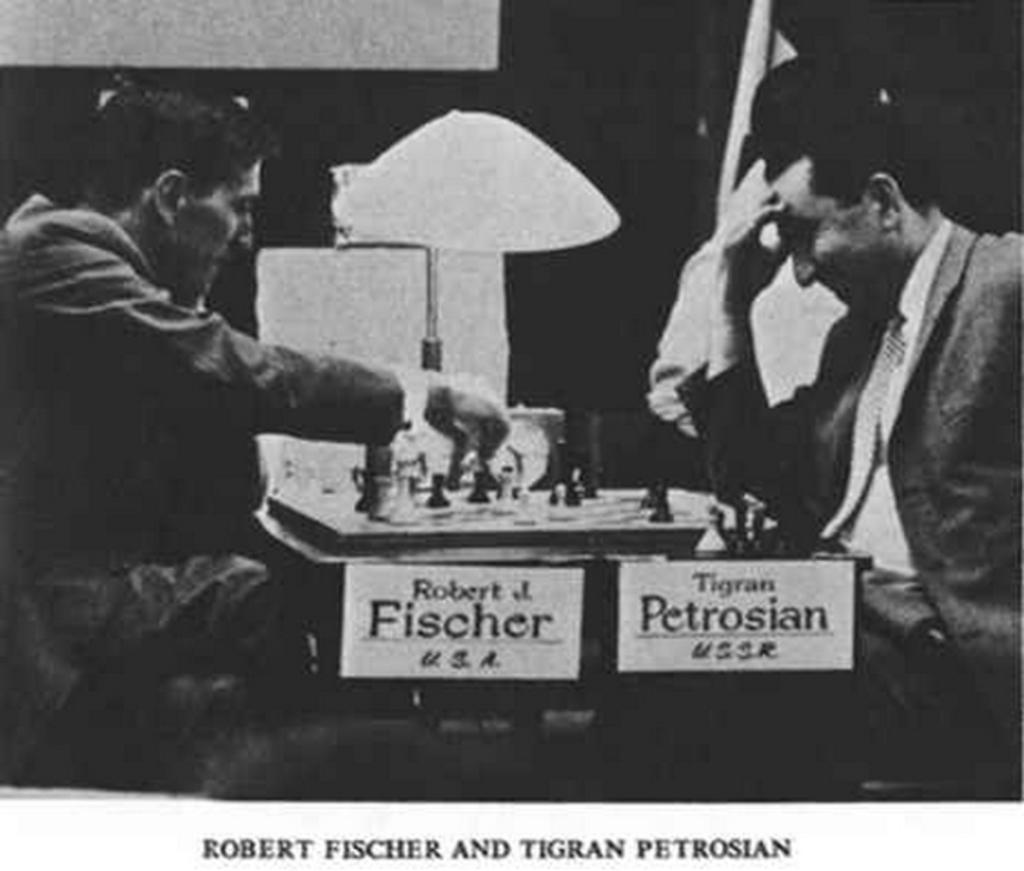How many people are present in the image? There are two people in the image. What are the two people doing in the image? The two people are playing chess. Where are the two people sitting while playing chess? The two people are sitting on chairs. On what surface is the chess game placed? The chess game is placed on a table. What color is the noise coming from the chess game in the image? There is no noise coming from the chess game in the image, and therefore no color can be associated with it. 